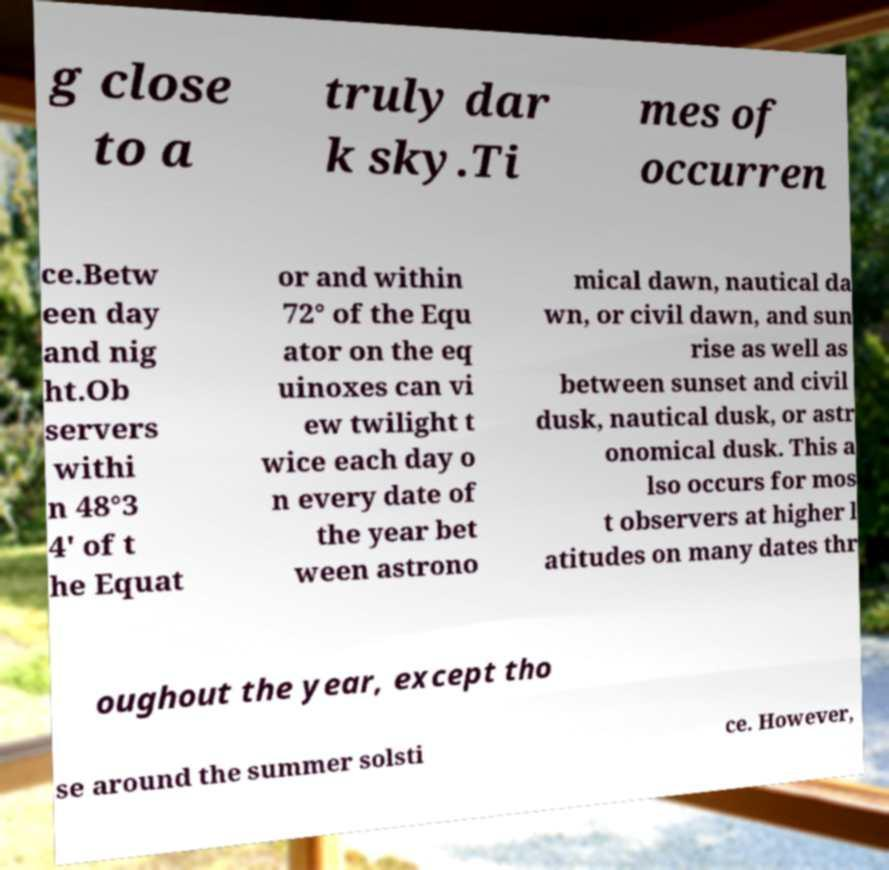There's text embedded in this image that I need extracted. Can you transcribe it verbatim? g close to a truly dar k sky.Ti mes of occurren ce.Betw een day and nig ht.Ob servers withi n 48°3 4' of t he Equat or and within 72° of the Equ ator on the eq uinoxes can vi ew twilight t wice each day o n every date of the year bet ween astrono mical dawn, nautical da wn, or civil dawn, and sun rise as well as between sunset and civil dusk, nautical dusk, or astr onomical dusk. This a lso occurs for mos t observers at higher l atitudes on many dates thr oughout the year, except tho se around the summer solsti ce. However, 